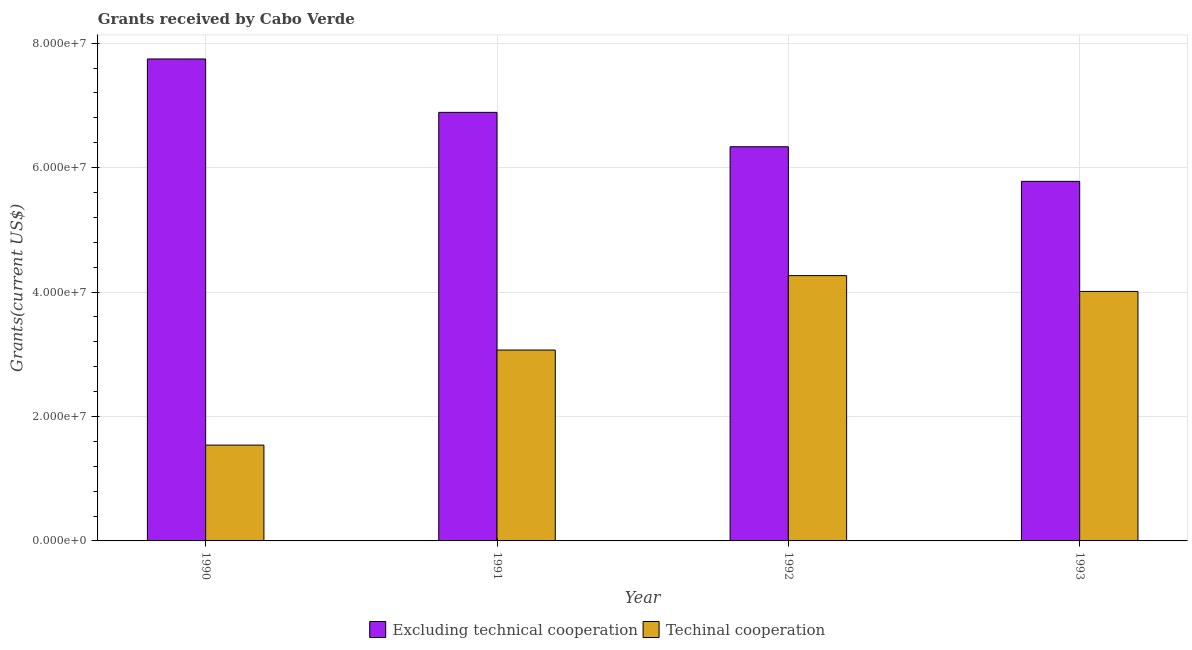How many different coloured bars are there?
Provide a succinct answer. 2. How many groups of bars are there?
Offer a terse response. 4. Are the number of bars per tick equal to the number of legend labels?
Make the answer very short. Yes. In how many cases, is the number of bars for a given year not equal to the number of legend labels?
Make the answer very short. 0. What is the amount of grants received(excluding technical cooperation) in 1993?
Make the answer very short. 5.78e+07. Across all years, what is the maximum amount of grants received(including technical cooperation)?
Offer a terse response. 4.26e+07. Across all years, what is the minimum amount of grants received(including technical cooperation)?
Your answer should be compact. 1.54e+07. What is the total amount of grants received(excluding technical cooperation) in the graph?
Offer a terse response. 2.67e+08. What is the difference between the amount of grants received(including technical cooperation) in 1991 and that in 1992?
Your answer should be compact. -1.20e+07. What is the difference between the amount of grants received(excluding technical cooperation) in 1991 and the amount of grants received(including technical cooperation) in 1992?
Your answer should be compact. 5.53e+06. What is the average amount of grants received(excluding technical cooperation) per year?
Keep it short and to the point. 6.69e+07. In the year 1991, what is the difference between the amount of grants received(excluding technical cooperation) and amount of grants received(including technical cooperation)?
Provide a short and direct response. 0. In how many years, is the amount of grants received(excluding technical cooperation) greater than 32000000 US$?
Your answer should be very brief. 4. What is the ratio of the amount of grants received(including technical cooperation) in 1990 to that in 1992?
Give a very brief answer. 0.36. Is the amount of grants received(including technical cooperation) in 1991 less than that in 1993?
Keep it short and to the point. Yes. What is the difference between the highest and the second highest amount of grants received(including technical cooperation)?
Keep it short and to the point. 2.54e+06. What is the difference between the highest and the lowest amount of grants received(including technical cooperation)?
Provide a short and direct response. 2.72e+07. Is the sum of the amount of grants received(including technical cooperation) in 1990 and 1991 greater than the maximum amount of grants received(excluding technical cooperation) across all years?
Your answer should be very brief. Yes. What does the 1st bar from the left in 1993 represents?
Provide a short and direct response. Excluding technical cooperation. What does the 1st bar from the right in 1990 represents?
Offer a very short reply. Techinal cooperation. How many bars are there?
Keep it short and to the point. 8. Are the values on the major ticks of Y-axis written in scientific E-notation?
Your answer should be compact. Yes. Does the graph contain any zero values?
Your response must be concise. No. Does the graph contain grids?
Your answer should be very brief. Yes. Where does the legend appear in the graph?
Your answer should be compact. Bottom center. What is the title of the graph?
Keep it short and to the point. Grants received by Cabo Verde. What is the label or title of the Y-axis?
Offer a very short reply. Grants(current US$). What is the Grants(current US$) in Excluding technical cooperation in 1990?
Offer a terse response. 7.75e+07. What is the Grants(current US$) in Techinal cooperation in 1990?
Your answer should be compact. 1.54e+07. What is the Grants(current US$) in Excluding technical cooperation in 1991?
Offer a very short reply. 6.89e+07. What is the Grants(current US$) of Techinal cooperation in 1991?
Provide a succinct answer. 3.07e+07. What is the Grants(current US$) of Excluding technical cooperation in 1992?
Ensure brevity in your answer.  6.34e+07. What is the Grants(current US$) in Techinal cooperation in 1992?
Offer a terse response. 4.26e+07. What is the Grants(current US$) in Excluding technical cooperation in 1993?
Offer a very short reply. 5.78e+07. What is the Grants(current US$) in Techinal cooperation in 1993?
Keep it short and to the point. 4.01e+07. Across all years, what is the maximum Grants(current US$) in Excluding technical cooperation?
Give a very brief answer. 7.75e+07. Across all years, what is the maximum Grants(current US$) in Techinal cooperation?
Provide a short and direct response. 4.26e+07. Across all years, what is the minimum Grants(current US$) of Excluding technical cooperation?
Ensure brevity in your answer.  5.78e+07. Across all years, what is the minimum Grants(current US$) of Techinal cooperation?
Offer a terse response. 1.54e+07. What is the total Grants(current US$) of Excluding technical cooperation in the graph?
Your answer should be very brief. 2.67e+08. What is the total Grants(current US$) in Techinal cooperation in the graph?
Offer a very short reply. 1.29e+08. What is the difference between the Grants(current US$) in Excluding technical cooperation in 1990 and that in 1991?
Offer a terse response. 8.58e+06. What is the difference between the Grants(current US$) of Techinal cooperation in 1990 and that in 1991?
Keep it short and to the point. -1.53e+07. What is the difference between the Grants(current US$) of Excluding technical cooperation in 1990 and that in 1992?
Provide a succinct answer. 1.41e+07. What is the difference between the Grants(current US$) of Techinal cooperation in 1990 and that in 1992?
Offer a very short reply. -2.72e+07. What is the difference between the Grants(current US$) of Excluding technical cooperation in 1990 and that in 1993?
Provide a short and direct response. 1.97e+07. What is the difference between the Grants(current US$) of Techinal cooperation in 1990 and that in 1993?
Keep it short and to the point. -2.47e+07. What is the difference between the Grants(current US$) of Excluding technical cooperation in 1991 and that in 1992?
Provide a short and direct response. 5.53e+06. What is the difference between the Grants(current US$) in Techinal cooperation in 1991 and that in 1992?
Provide a succinct answer. -1.20e+07. What is the difference between the Grants(current US$) in Excluding technical cooperation in 1991 and that in 1993?
Offer a terse response. 1.11e+07. What is the difference between the Grants(current US$) in Techinal cooperation in 1991 and that in 1993?
Ensure brevity in your answer.  -9.42e+06. What is the difference between the Grants(current US$) of Excluding technical cooperation in 1992 and that in 1993?
Give a very brief answer. 5.56e+06. What is the difference between the Grants(current US$) of Techinal cooperation in 1992 and that in 1993?
Make the answer very short. 2.54e+06. What is the difference between the Grants(current US$) in Excluding technical cooperation in 1990 and the Grants(current US$) in Techinal cooperation in 1991?
Provide a succinct answer. 4.68e+07. What is the difference between the Grants(current US$) of Excluding technical cooperation in 1990 and the Grants(current US$) of Techinal cooperation in 1992?
Keep it short and to the point. 3.48e+07. What is the difference between the Grants(current US$) of Excluding technical cooperation in 1990 and the Grants(current US$) of Techinal cooperation in 1993?
Ensure brevity in your answer.  3.74e+07. What is the difference between the Grants(current US$) in Excluding technical cooperation in 1991 and the Grants(current US$) in Techinal cooperation in 1992?
Offer a very short reply. 2.62e+07. What is the difference between the Grants(current US$) in Excluding technical cooperation in 1991 and the Grants(current US$) in Techinal cooperation in 1993?
Ensure brevity in your answer.  2.88e+07. What is the difference between the Grants(current US$) in Excluding technical cooperation in 1992 and the Grants(current US$) in Techinal cooperation in 1993?
Your answer should be compact. 2.32e+07. What is the average Grants(current US$) in Excluding technical cooperation per year?
Offer a very short reply. 6.69e+07. What is the average Grants(current US$) of Techinal cooperation per year?
Provide a short and direct response. 3.22e+07. In the year 1990, what is the difference between the Grants(current US$) of Excluding technical cooperation and Grants(current US$) of Techinal cooperation?
Make the answer very short. 6.21e+07. In the year 1991, what is the difference between the Grants(current US$) of Excluding technical cooperation and Grants(current US$) of Techinal cooperation?
Your answer should be compact. 3.82e+07. In the year 1992, what is the difference between the Grants(current US$) in Excluding technical cooperation and Grants(current US$) in Techinal cooperation?
Keep it short and to the point. 2.07e+07. In the year 1993, what is the difference between the Grants(current US$) of Excluding technical cooperation and Grants(current US$) of Techinal cooperation?
Keep it short and to the point. 1.77e+07. What is the ratio of the Grants(current US$) of Excluding technical cooperation in 1990 to that in 1991?
Keep it short and to the point. 1.12. What is the ratio of the Grants(current US$) in Techinal cooperation in 1990 to that in 1991?
Give a very brief answer. 0.5. What is the ratio of the Grants(current US$) of Excluding technical cooperation in 1990 to that in 1992?
Offer a very short reply. 1.22. What is the ratio of the Grants(current US$) in Techinal cooperation in 1990 to that in 1992?
Give a very brief answer. 0.36. What is the ratio of the Grants(current US$) of Excluding technical cooperation in 1990 to that in 1993?
Give a very brief answer. 1.34. What is the ratio of the Grants(current US$) of Techinal cooperation in 1990 to that in 1993?
Make the answer very short. 0.38. What is the ratio of the Grants(current US$) of Excluding technical cooperation in 1991 to that in 1992?
Offer a terse response. 1.09. What is the ratio of the Grants(current US$) of Techinal cooperation in 1991 to that in 1992?
Provide a short and direct response. 0.72. What is the ratio of the Grants(current US$) in Excluding technical cooperation in 1991 to that in 1993?
Your response must be concise. 1.19. What is the ratio of the Grants(current US$) of Techinal cooperation in 1991 to that in 1993?
Ensure brevity in your answer.  0.77. What is the ratio of the Grants(current US$) of Excluding technical cooperation in 1992 to that in 1993?
Your answer should be compact. 1.1. What is the ratio of the Grants(current US$) in Techinal cooperation in 1992 to that in 1993?
Your answer should be compact. 1.06. What is the difference between the highest and the second highest Grants(current US$) in Excluding technical cooperation?
Provide a succinct answer. 8.58e+06. What is the difference between the highest and the second highest Grants(current US$) of Techinal cooperation?
Offer a very short reply. 2.54e+06. What is the difference between the highest and the lowest Grants(current US$) in Excluding technical cooperation?
Ensure brevity in your answer.  1.97e+07. What is the difference between the highest and the lowest Grants(current US$) of Techinal cooperation?
Keep it short and to the point. 2.72e+07. 